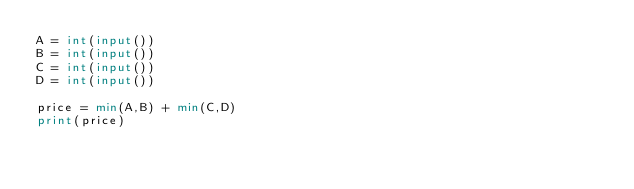Convert code to text. <code><loc_0><loc_0><loc_500><loc_500><_Python_>A = int(input())
B = int(input())
C = int(input())
D = int(input())

price = min(A,B) + min(C,D)
print(price)</code> 